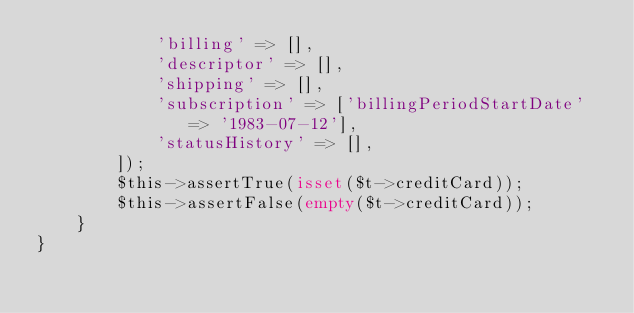Convert code to text. <code><loc_0><loc_0><loc_500><loc_500><_PHP_>            'billing' => [],
            'descriptor' => [],
            'shipping' => [],
            'subscription' => ['billingPeriodStartDate' => '1983-07-12'],
            'statusHistory' => [],
        ]);
        $this->assertTrue(isset($t->creditCard));
        $this->assertFalse(empty($t->creditCard));
    }
}
</code> 